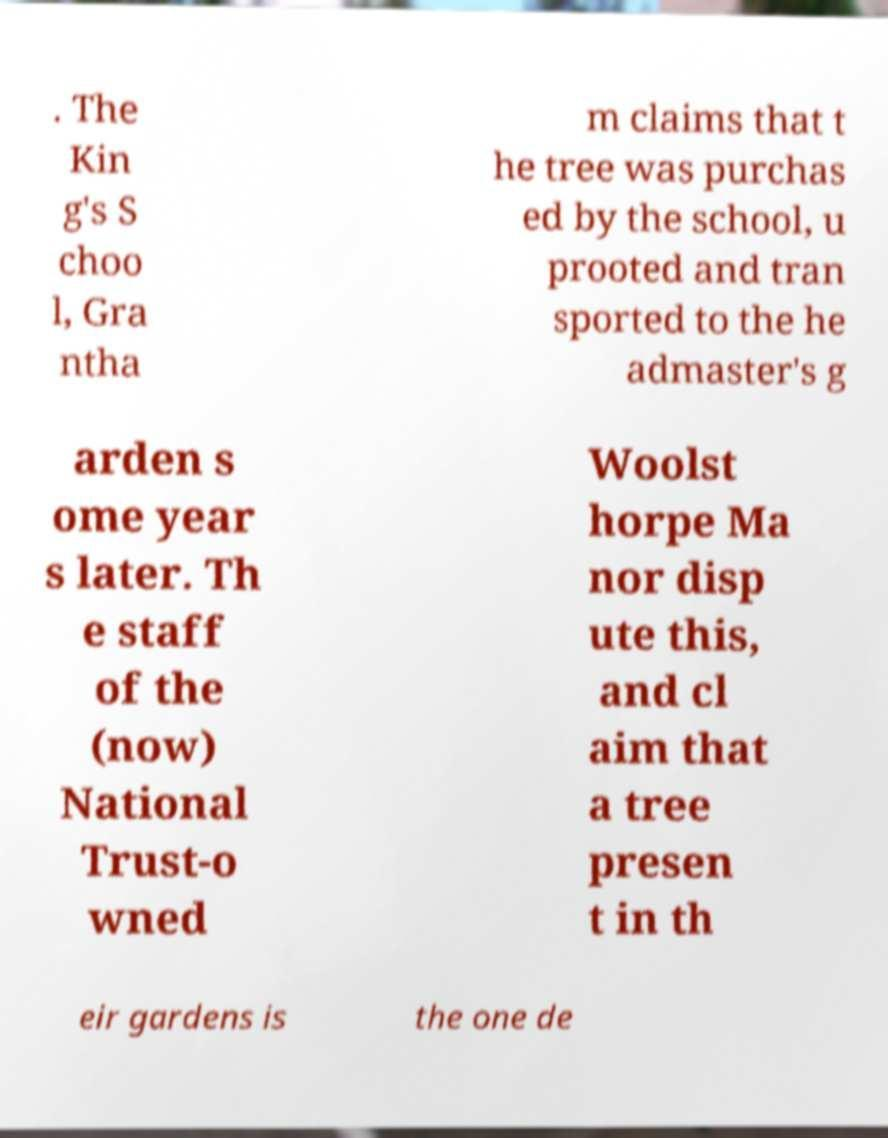Please identify and transcribe the text found in this image. . The Kin g's S choo l, Gra ntha m claims that t he tree was purchas ed by the school, u prooted and tran sported to the he admaster's g arden s ome year s later. Th e staff of the (now) National Trust-o wned Woolst horpe Ma nor disp ute this, and cl aim that a tree presen t in th eir gardens is the one de 